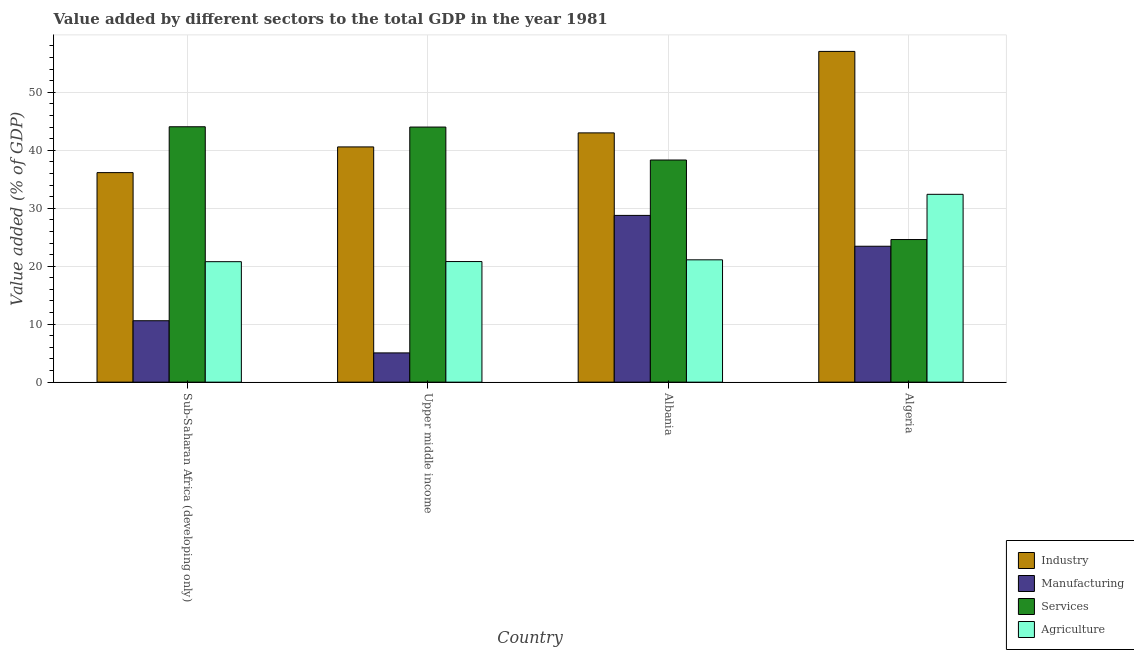How many different coloured bars are there?
Make the answer very short. 4. How many groups of bars are there?
Offer a very short reply. 4. Are the number of bars per tick equal to the number of legend labels?
Keep it short and to the point. Yes. Are the number of bars on each tick of the X-axis equal?
Provide a short and direct response. Yes. How many bars are there on the 4th tick from the left?
Keep it short and to the point. 4. How many bars are there on the 1st tick from the right?
Offer a very short reply. 4. What is the label of the 3rd group of bars from the left?
Give a very brief answer. Albania. In how many cases, is the number of bars for a given country not equal to the number of legend labels?
Provide a succinct answer. 0. What is the value added by agricultural sector in Upper middle income?
Your answer should be compact. 20.8. Across all countries, what is the maximum value added by industrial sector?
Keep it short and to the point. 57.05. Across all countries, what is the minimum value added by services sector?
Your answer should be compact. 24.6. In which country was the value added by services sector maximum?
Make the answer very short. Sub-Saharan Africa (developing only). In which country was the value added by services sector minimum?
Your response must be concise. Algeria. What is the total value added by services sector in the graph?
Keep it short and to the point. 150.98. What is the difference between the value added by manufacturing sector in Albania and that in Sub-Saharan Africa (developing only)?
Keep it short and to the point. 18.17. What is the difference between the value added by services sector in Algeria and the value added by manufacturing sector in Upper middle income?
Offer a very short reply. 19.55. What is the average value added by industrial sector per country?
Your answer should be very brief. 44.19. What is the difference between the value added by industrial sector and value added by services sector in Albania?
Your answer should be compact. 4.68. What is the ratio of the value added by services sector in Albania to that in Sub-Saharan Africa (developing only)?
Offer a terse response. 0.87. Is the value added by agricultural sector in Algeria less than that in Sub-Saharan Africa (developing only)?
Offer a very short reply. No. Is the difference between the value added by industrial sector in Algeria and Sub-Saharan Africa (developing only) greater than the difference between the value added by agricultural sector in Algeria and Sub-Saharan Africa (developing only)?
Your response must be concise. Yes. What is the difference between the highest and the second highest value added by industrial sector?
Give a very brief answer. 14.05. What is the difference between the highest and the lowest value added by industrial sector?
Make the answer very short. 20.91. In how many countries, is the value added by manufacturing sector greater than the average value added by manufacturing sector taken over all countries?
Give a very brief answer. 2. Is the sum of the value added by agricultural sector in Albania and Sub-Saharan Africa (developing only) greater than the maximum value added by industrial sector across all countries?
Make the answer very short. No. Is it the case that in every country, the sum of the value added by agricultural sector and value added by industrial sector is greater than the sum of value added by manufacturing sector and value added by services sector?
Provide a short and direct response. Yes. What does the 4th bar from the left in Upper middle income represents?
Offer a terse response. Agriculture. What does the 4th bar from the right in Albania represents?
Provide a succinct answer. Industry. Are all the bars in the graph horizontal?
Your response must be concise. No. How many countries are there in the graph?
Your response must be concise. 4. Are the values on the major ticks of Y-axis written in scientific E-notation?
Your answer should be compact. No. Does the graph contain any zero values?
Make the answer very short. No. What is the title of the graph?
Keep it short and to the point. Value added by different sectors to the total GDP in the year 1981. Does "Primary" appear as one of the legend labels in the graph?
Keep it short and to the point. No. What is the label or title of the X-axis?
Provide a succinct answer. Country. What is the label or title of the Y-axis?
Ensure brevity in your answer.  Value added (% of GDP). What is the Value added (% of GDP) in Industry in Sub-Saharan Africa (developing only)?
Give a very brief answer. 36.15. What is the Value added (% of GDP) in Manufacturing in Sub-Saharan Africa (developing only)?
Your answer should be compact. 10.59. What is the Value added (% of GDP) in Services in Sub-Saharan Africa (developing only)?
Keep it short and to the point. 44.06. What is the Value added (% of GDP) of Agriculture in Sub-Saharan Africa (developing only)?
Provide a short and direct response. 20.78. What is the Value added (% of GDP) in Industry in Upper middle income?
Provide a short and direct response. 40.58. What is the Value added (% of GDP) of Manufacturing in Upper middle income?
Provide a short and direct response. 5.05. What is the Value added (% of GDP) of Services in Upper middle income?
Give a very brief answer. 44.01. What is the Value added (% of GDP) of Agriculture in Upper middle income?
Your answer should be very brief. 20.8. What is the Value added (% of GDP) of Industry in Albania?
Your response must be concise. 43. What is the Value added (% of GDP) in Manufacturing in Albania?
Provide a short and direct response. 28.77. What is the Value added (% of GDP) in Services in Albania?
Keep it short and to the point. 38.32. What is the Value added (% of GDP) of Agriculture in Albania?
Provide a succinct answer. 21.1. What is the Value added (% of GDP) in Industry in Algeria?
Offer a very short reply. 57.05. What is the Value added (% of GDP) in Manufacturing in Algeria?
Make the answer very short. 23.44. What is the Value added (% of GDP) of Services in Algeria?
Make the answer very short. 24.6. What is the Value added (% of GDP) in Agriculture in Algeria?
Your answer should be very brief. 32.4. Across all countries, what is the maximum Value added (% of GDP) of Industry?
Ensure brevity in your answer.  57.05. Across all countries, what is the maximum Value added (% of GDP) in Manufacturing?
Your response must be concise. 28.77. Across all countries, what is the maximum Value added (% of GDP) of Services?
Provide a succinct answer. 44.06. Across all countries, what is the maximum Value added (% of GDP) in Agriculture?
Provide a short and direct response. 32.4. Across all countries, what is the minimum Value added (% of GDP) of Industry?
Offer a terse response. 36.15. Across all countries, what is the minimum Value added (% of GDP) of Manufacturing?
Give a very brief answer. 5.05. Across all countries, what is the minimum Value added (% of GDP) in Services?
Provide a succinct answer. 24.6. Across all countries, what is the minimum Value added (% of GDP) in Agriculture?
Make the answer very short. 20.78. What is the total Value added (% of GDP) of Industry in the graph?
Your response must be concise. 176.78. What is the total Value added (% of GDP) in Manufacturing in the graph?
Ensure brevity in your answer.  67.85. What is the total Value added (% of GDP) in Services in the graph?
Make the answer very short. 150.98. What is the total Value added (% of GDP) in Agriculture in the graph?
Provide a succinct answer. 95.09. What is the difference between the Value added (% of GDP) of Industry in Sub-Saharan Africa (developing only) and that in Upper middle income?
Give a very brief answer. -4.43. What is the difference between the Value added (% of GDP) in Manufacturing in Sub-Saharan Africa (developing only) and that in Upper middle income?
Your response must be concise. 5.55. What is the difference between the Value added (% of GDP) of Services in Sub-Saharan Africa (developing only) and that in Upper middle income?
Give a very brief answer. 0.05. What is the difference between the Value added (% of GDP) in Agriculture in Sub-Saharan Africa (developing only) and that in Upper middle income?
Ensure brevity in your answer.  -0.02. What is the difference between the Value added (% of GDP) in Industry in Sub-Saharan Africa (developing only) and that in Albania?
Ensure brevity in your answer.  -6.86. What is the difference between the Value added (% of GDP) in Manufacturing in Sub-Saharan Africa (developing only) and that in Albania?
Keep it short and to the point. -18.17. What is the difference between the Value added (% of GDP) in Services in Sub-Saharan Africa (developing only) and that in Albania?
Your answer should be very brief. 5.74. What is the difference between the Value added (% of GDP) of Agriculture in Sub-Saharan Africa (developing only) and that in Albania?
Give a very brief answer. -0.32. What is the difference between the Value added (% of GDP) in Industry in Sub-Saharan Africa (developing only) and that in Algeria?
Provide a succinct answer. -20.91. What is the difference between the Value added (% of GDP) in Manufacturing in Sub-Saharan Africa (developing only) and that in Algeria?
Your answer should be very brief. -12.85. What is the difference between the Value added (% of GDP) in Services in Sub-Saharan Africa (developing only) and that in Algeria?
Make the answer very short. 19.46. What is the difference between the Value added (% of GDP) of Agriculture in Sub-Saharan Africa (developing only) and that in Algeria?
Your answer should be compact. -11.62. What is the difference between the Value added (% of GDP) of Industry in Upper middle income and that in Albania?
Your answer should be compact. -2.42. What is the difference between the Value added (% of GDP) of Manufacturing in Upper middle income and that in Albania?
Offer a terse response. -23.72. What is the difference between the Value added (% of GDP) of Services in Upper middle income and that in Albania?
Give a very brief answer. 5.69. What is the difference between the Value added (% of GDP) in Agriculture in Upper middle income and that in Albania?
Make the answer very short. -0.3. What is the difference between the Value added (% of GDP) of Industry in Upper middle income and that in Algeria?
Offer a very short reply. -16.47. What is the difference between the Value added (% of GDP) of Manufacturing in Upper middle income and that in Algeria?
Offer a terse response. -18.4. What is the difference between the Value added (% of GDP) of Services in Upper middle income and that in Algeria?
Your answer should be compact. 19.41. What is the difference between the Value added (% of GDP) of Agriculture in Upper middle income and that in Algeria?
Give a very brief answer. -11.6. What is the difference between the Value added (% of GDP) in Industry in Albania and that in Algeria?
Provide a succinct answer. -14.05. What is the difference between the Value added (% of GDP) of Manufacturing in Albania and that in Algeria?
Offer a terse response. 5.32. What is the difference between the Value added (% of GDP) of Services in Albania and that in Algeria?
Keep it short and to the point. 13.72. What is the difference between the Value added (% of GDP) in Agriculture in Albania and that in Algeria?
Offer a terse response. -11.3. What is the difference between the Value added (% of GDP) in Industry in Sub-Saharan Africa (developing only) and the Value added (% of GDP) in Manufacturing in Upper middle income?
Provide a succinct answer. 31.1. What is the difference between the Value added (% of GDP) of Industry in Sub-Saharan Africa (developing only) and the Value added (% of GDP) of Services in Upper middle income?
Your answer should be compact. -7.86. What is the difference between the Value added (% of GDP) of Industry in Sub-Saharan Africa (developing only) and the Value added (% of GDP) of Agriculture in Upper middle income?
Make the answer very short. 15.34. What is the difference between the Value added (% of GDP) of Manufacturing in Sub-Saharan Africa (developing only) and the Value added (% of GDP) of Services in Upper middle income?
Give a very brief answer. -33.41. What is the difference between the Value added (% of GDP) in Manufacturing in Sub-Saharan Africa (developing only) and the Value added (% of GDP) in Agriculture in Upper middle income?
Provide a succinct answer. -10.21. What is the difference between the Value added (% of GDP) of Services in Sub-Saharan Africa (developing only) and the Value added (% of GDP) of Agriculture in Upper middle income?
Provide a succinct answer. 23.25. What is the difference between the Value added (% of GDP) of Industry in Sub-Saharan Africa (developing only) and the Value added (% of GDP) of Manufacturing in Albania?
Provide a short and direct response. 7.38. What is the difference between the Value added (% of GDP) of Industry in Sub-Saharan Africa (developing only) and the Value added (% of GDP) of Services in Albania?
Your response must be concise. -2.17. What is the difference between the Value added (% of GDP) of Industry in Sub-Saharan Africa (developing only) and the Value added (% of GDP) of Agriculture in Albania?
Your answer should be compact. 15.04. What is the difference between the Value added (% of GDP) in Manufacturing in Sub-Saharan Africa (developing only) and the Value added (% of GDP) in Services in Albania?
Give a very brief answer. -27.73. What is the difference between the Value added (% of GDP) in Manufacturing in Sub-Saharan Africa (developing only) and the Value added (% of GDP) in Agriculture in Albania?
Ensure brevity in your answer.  -10.51. What is the difference between the Value added (% of GDP) in Services in Sub-Saharan Africa (developing only) and the Value added (% of GDP) in Agriculture in Albania?
Your answer should be compact. 22.95. What is the difference between the Value added (% of GDP) in Industry in Sub-Saharan Africa (developing only) and the Value added (% of GDP) in Manufacturing in Algeria?
Give a very brief answer. 12.7. What is the difference between the Value added (% of GDP) in Industry in Sub-Saharan Africa (developing only) and the Value added (% of GDP) in Services in Algeria?
Keep it short and to the point. 11.55. What is the difference between the Value added (% of GDP) in Industry in Sub-Saharan Africa (developing only) and the Value added (% of GDP) in Agriculture in Algeria?
Offer a terse response. 3.74. What is the difference between the Value added (% of GDP) of Manufacturing in Sub-Saharan Africa (developing only) and the Value added (% of GDP) of Services in Algeria?
Your response must be concise. -14. What is the difference between the Value added (% of GDP) of Manufacturing in Sub-Saharan Africa (developing only) and the Value added (% of GDP) of Agriculture in Algeria?
Provide a short and direct response. -21.81. What is the difference between the Value added (% of GDP) in Services in Sub-Saharan Africa (developing only) and the Value added (% of GDP) in Agriculture in Algeria?
Provide a succinct answer. 11.66. What is the difference between the Value added (% of GDP) in Industry in Upper middle income and the Value added (% of GDP) in Manufacturing in Albania?
Provide a short and direct response. 11.81. What is the difference between the Value added (% of GDP) in Industry in Upper middle income and the Value added (% of GDP) in Services in Albania?
Your answer should be compact. 2.26. What is the difference between the Value added (% of GDP) of Industry in Upper middle income and the Value added (% of GDP) of Agriculture in Albania?
Your answer should be compact. 19.48. What is the difference between the Value added (% of GDP) of Manufacturing in Upper middle income and the Value added (% of GDP) of Services in Albania?
Make the answer very short. -33.27. What is the difference between the Value added (% of GDP) of Manufacturing in Upper middle income and the Value added (% of GDP) of Agriculture in Albania?
Make the answer very short. -16.06. What is the difference between the Value added (% of GDP) of Services in Upper middle income and the Value added (% of GDP) of Agriculture in Albania?
Your response must be concise. 22.9. What is the difference between the Value added (% of GDP) of Industry in Upper middle income and the Value added (% of GDP) of Manufacturing in Algeria?
Give a very brief answer. 17.13. What is the difference between the Value added (% of GDP) in Industry in Upper middle income and the Value added (% of GDP) in Services in Algeria?
Your answer should be compact. 15.98. What is the difference between the Value added (% of GDP) in Industry in Upper middle income and the Value added (% of GDP) in Agriculture in Algeria?
Ensure brevity in your answer.  8.18. What is the difference between the Value added (% of GDP) in Manufacturing in Upper middle income and the Value added (% of GDP) in Services in Algeria?
Give a very brief answer. -19.55. What is the difference between the Value added (% of GDP) in Manufacturing in Upper middle income and the Value added (% of GDP) in Agriculture in Algeria?
Make the answer very short. -27.36. What is the difference between the Value added (% of GDP) of Services in Upper middle income and the Value added (% of GDP) of Agriculture in Algeria?
Provide a succinct answer. 11.61. What is the difference between the Value added (% of GDP) of Industry in Albania and the Value added (% of GDP) of Manufacturing in Algeria?
Your answer should be very brief. 19.56. What is the difference between the Value added (% of GDP) of Industry in Albania and the Value added (% of GDP) of Services in Algeria?
Your response must be concise. 18.4. What is the difference between the Value added (% of GDP) in Industry in Albania and the Value added (% of GDP) in Agriculture in Algeria?
Your answer should be very brief. 10.6. What is the difference between the Value added (% of GDP) in Manufacturing in Albania and the Value added (% of GDP) in Services in Algeria?
Your response must be concise. 4.17. What is the difference between the Value added (% of GDP) of Manufacturing in Albania and the Value added (% of GDP) of Agriculture in Algeria?
Keep it short and to the point. -3.64. What is the difference between the Value added (% of GDP) in Services in Albania and the Value added (% of GDP) in Agriculture in Algeria?
Offer a very short reply. 5.92. What is the average Value added (% of GDP) in Industry per country?
Keep it short and to the point. 44.19. What is the average Value added (% of GDP) in Manufacturing per country?
Offer a very short reply. 16.96. What is the average Value added (% of GDP) in Services per country?
Offer a terse response. 37.75. What is the average Value added (% of GDP) in Agriculture per country?
Offer a very short reply. 23.77. What is the difference between the Value added (% of GDP) of Industry and Value added (% of GDP) of Manufacturing in Sub-Saharan Africa (developing only)?
Offer a terse response. 25.55. What is the difference between the Value added (% of GDP) in Industry and Value added (% of GDP) in Services in Sub-Saharan Africa (developing only)?
Offer a terse response. -7.91. What is the difference between the Value added (% of GDP) of Industry and Value added (% of GDP) of Agriculture in Sub-Saharan Africa (developing only)?
Your response must be concise. 15.36. What is the difference between the Value added (% of GDP) in Manufacturing and Value added (% of GDP) in Services in Sub-Saharan Africa (developing only)?
Offer a very short reply. -33.46. What is the difference between the Value added (% of GDP) of Manufacturing and Value added (% of GDP) of Agriculture in Sub-Saharan Africa (developing only)?
Provide a succinct answer. -10.19. What is the difference between the Value added (% of GDP) in Services and Value added (% of GDP) in Agriculture in Sub-Saharan Africa (developing only)?
Give a very brief answer. 23.27. What is the difference between the Value added (% of GDP) in Industry and Value added (% of GDP) in Manufacturing in Upper middle income?
Keep it short and to the point. 35.53. What is the difference between the Value added (% of GDP) in Industry and Value added (% of GDP) in Services in Upper middle income?
Your answer should be compact. -3.43. What is the difference between the Value added (% of GDP) of Industry and Value added (% of GDP) of Agriculture in Upper middle income?
Your answer should be very brief. 19.78. What is the difference between the Value added (% of GDP) in Manufacturing and Value added (% of GDP) in Services in Upper middle income?
Your answer should be compact. -38.96. What is the difference between the Value added (% of GDP) in Manufacturing and Value added (% of GDP) in Agriculture in Upper middle income?
Offer a terse response. -15.76. What is the difference between the Value added (% of GDP) in Services and Value added (% of GDP) in Agriculture in Upper middle income?
Make the answer very short. 23.2. What is the difference between the Value added (% of GDP) of Industry and Value added (% of GDP) of Manufacturing in Albania?
Ensure brevity in your answer.  14.23. What is the difference between the Value added (% of GDP) in Industry and Value added (% of GDP) in Services in Albania?
Make the answer very short. 4.68. What is the difference between the Value added (% of GDP) of Industry and Value added (% of GDP) of Agriculture in Albania?
Provide a short and direct response. 21.9. What is the difference between the Value added (% of GDP) in Manufacturing and Value added (% of GDP) in Services in Albania?
Your answer should be very brief. -9.55. What is the difference between the Value added (% of GDP) of Manufacturing and Value added (% of GDP) of Agriculture in Albania?
Your answer should be very brief. 7.66. What is the difference between the Value added (% of GDP) of Services and Value added (% of GDP) of Agriculture in Albania?
Ensure brevity in your answer.  17.22. What is the difference between the Value added (% of GDP) in Industry and Value added (% of GDP) in Manufacturing in Algeria?
Give a very brief answer. 33.61. What is the difference between the Value added (% of GDP) of Industry and Value added (% of GDP) of Services in Algeria?
Give a very brief answer. 32.45. What is the difference between the Value added (% of GDP) in Industry and Value added (% of GDP) in Agriculture in Algeria?
Offer a very short reply. 24.65. What is the difference between the Value added (% of GDP) of Manufacturing and Value added (% of GDP) of Services in Algeria?
Provide a short and direct response. -1.15. What is the difference between the Value added (% of GDP) in Manufacturing and Value added (% of GDP) in Agriculture in Algeria?
Your answer should be compact. -8.96. What is the difference between the Value added (% of GDP) in Services and Value added (% of GDP) in Agriculture in Algeria?
Make the answer very short. -7.8. What is the ratio of the Value added (% of GDP) of Industry in Sub-Saharan Africa (developing only) to that in Upper middle income?
Ensure brevity in your answer.  0.89. What is the ratio of the Value added (% of GDP) in Manufacturing in Sub-Saharan Africa (developing only) to that in Upper middle income?
Keep it short and to the point. 2.1. What is the ratio of the Value added (% of GDP) in Services in Sub-Saharan Africa (developing only) to that in Upper middle income?
Keep it short and to the point. 1. What is the ratio of the Value added (% of GDP) of Agriculture in Sub-Saharan Africa (developing only) to that in Upper middle income?
Provide a succinct answer. 1. What is the ratio of the Value added (% of GDP) in Industry in Sub-Saharan Africa (developing only) to that in Albania?
Your answer should be compact. 0.84. What is the ratio of the Value added (% of GDP) of Manufacturing in Sub-Saharan Africa (developing only) to that in Albania?
Provide a short and direct response. 0.37. What is the ratio of the Value added (% of GDP) in Services in Sub-Saharan Africa (developing only) to that in Albania?
Your answer should be very brief. 1.15. What is the ratio of the Value added (% of GDP) in Agriculture in Sub-Saharan Africa (developing only) to that in Albania?
Ensure brevity in your answer.  0.98. What is the ratio of the Value added (% of GDP) in Industry in Sub-Saharan Africa (developing only) to that in Algeria?
Make the answer very short. 0.63. What is the ratio of the Value added (% of GDP) of Manufacturing in Sub-Saharan Africa (developing only) to that in Algeria?
Provide a succinct answer. 0.45. What is the ratio of the Value added (% of GDP) of Services in Sub-Saharan Africa (developing only) to that in Algeria?
Provide a short and direct response. 1.79. What is the ratio of the Value added (% of GDP) in Agriculture in Sub-Saharan Africa (developing only) to that in Algeria?
Keep it short and to the point. 0.64. What is the ratio of the Value added (% of GDP) in Industry in Upper middle income to that in Albania?
Ensure brevity in your answer.  0.94. What is the ratio of the Value added (% of GDP) of Manufacturing in Upper middle income to that in Albania?
Make the answer very short. 0.18. What is the ratio of the Value added (% of GDP) of Services in Upper middle income to that in Albania?
Offer a very short reply. 1.15. What is the ratio of the Value added (% of GDP) of Agriculture in Upper middle income to that in Albania?
Provide a succinct answer. 0.99. What is the ratio of the Value added (% of GDP) in Industry in Upper middle income to that in Algeria?
Offer a very short reply. 0.71. What is the ratio of the Value added (% of GDP) in Manufacturing in Upper middle income to that in Algeria?
Your response must be concise. 0.22. What is the ratio of the Value added (% of GDP) in Services in Upper middle income to that in Algeria?
Keep it short and to the point. 1.79. What is the ratio of the Value added (% of GDP) in Agriculture in Upper middle income to that in Algeria?
Offer a terse response. 0.64. What is the ratio of the Value added (% of GDP) in Industry in Albania to that in Algeria?
Keep it short and to the point. 0.75. What is the ratio of the Value added (% of GDP) of Manufacturing in Albania to that in Algeria?
Your response must be concise. 1.23. What is the ratio of the Value added (% of GDP) in Services in Albania to that in Algeria?
Your answer should be compact. 1.56. What is the ratio of the Value added (% of GDP) of Agriculture in Albania to that in Algeria?
Give a very brief answer. 0.65. What is the difference between the highest and the second highest Value added (% of GDP) in Industry?
Your answer should be compact. 14.05. What is the difference between the highest and the second highest Value added (% of GDP) in Manufacturing?
Make the answer very short. 5.32. What is the difference between the highest and the second highest Value added (% of GDP) in Services?
Offer a terse response. 0.05. What is the difference between the highest and the second highest Value added (% of GDP) of Agriculture?
Provide a short and direct response. 11.3. What is the difference between the highest and the lowest Value added (% of GDP) in Industry?
Make the answer very short. 20.91. What is the difference between the highest and the lowest Value added (% of GDP) in Manufacturing?
Provide a short and direct response. 23.72. What is the difference between the highest and the lowest Value added (% of GDP) in Services?
Make the answer very short. 19.46. What is the difference between the highest and the lowest Value added (% of GDP) in Agriculture?
Offer a very short reply. 11.62. 